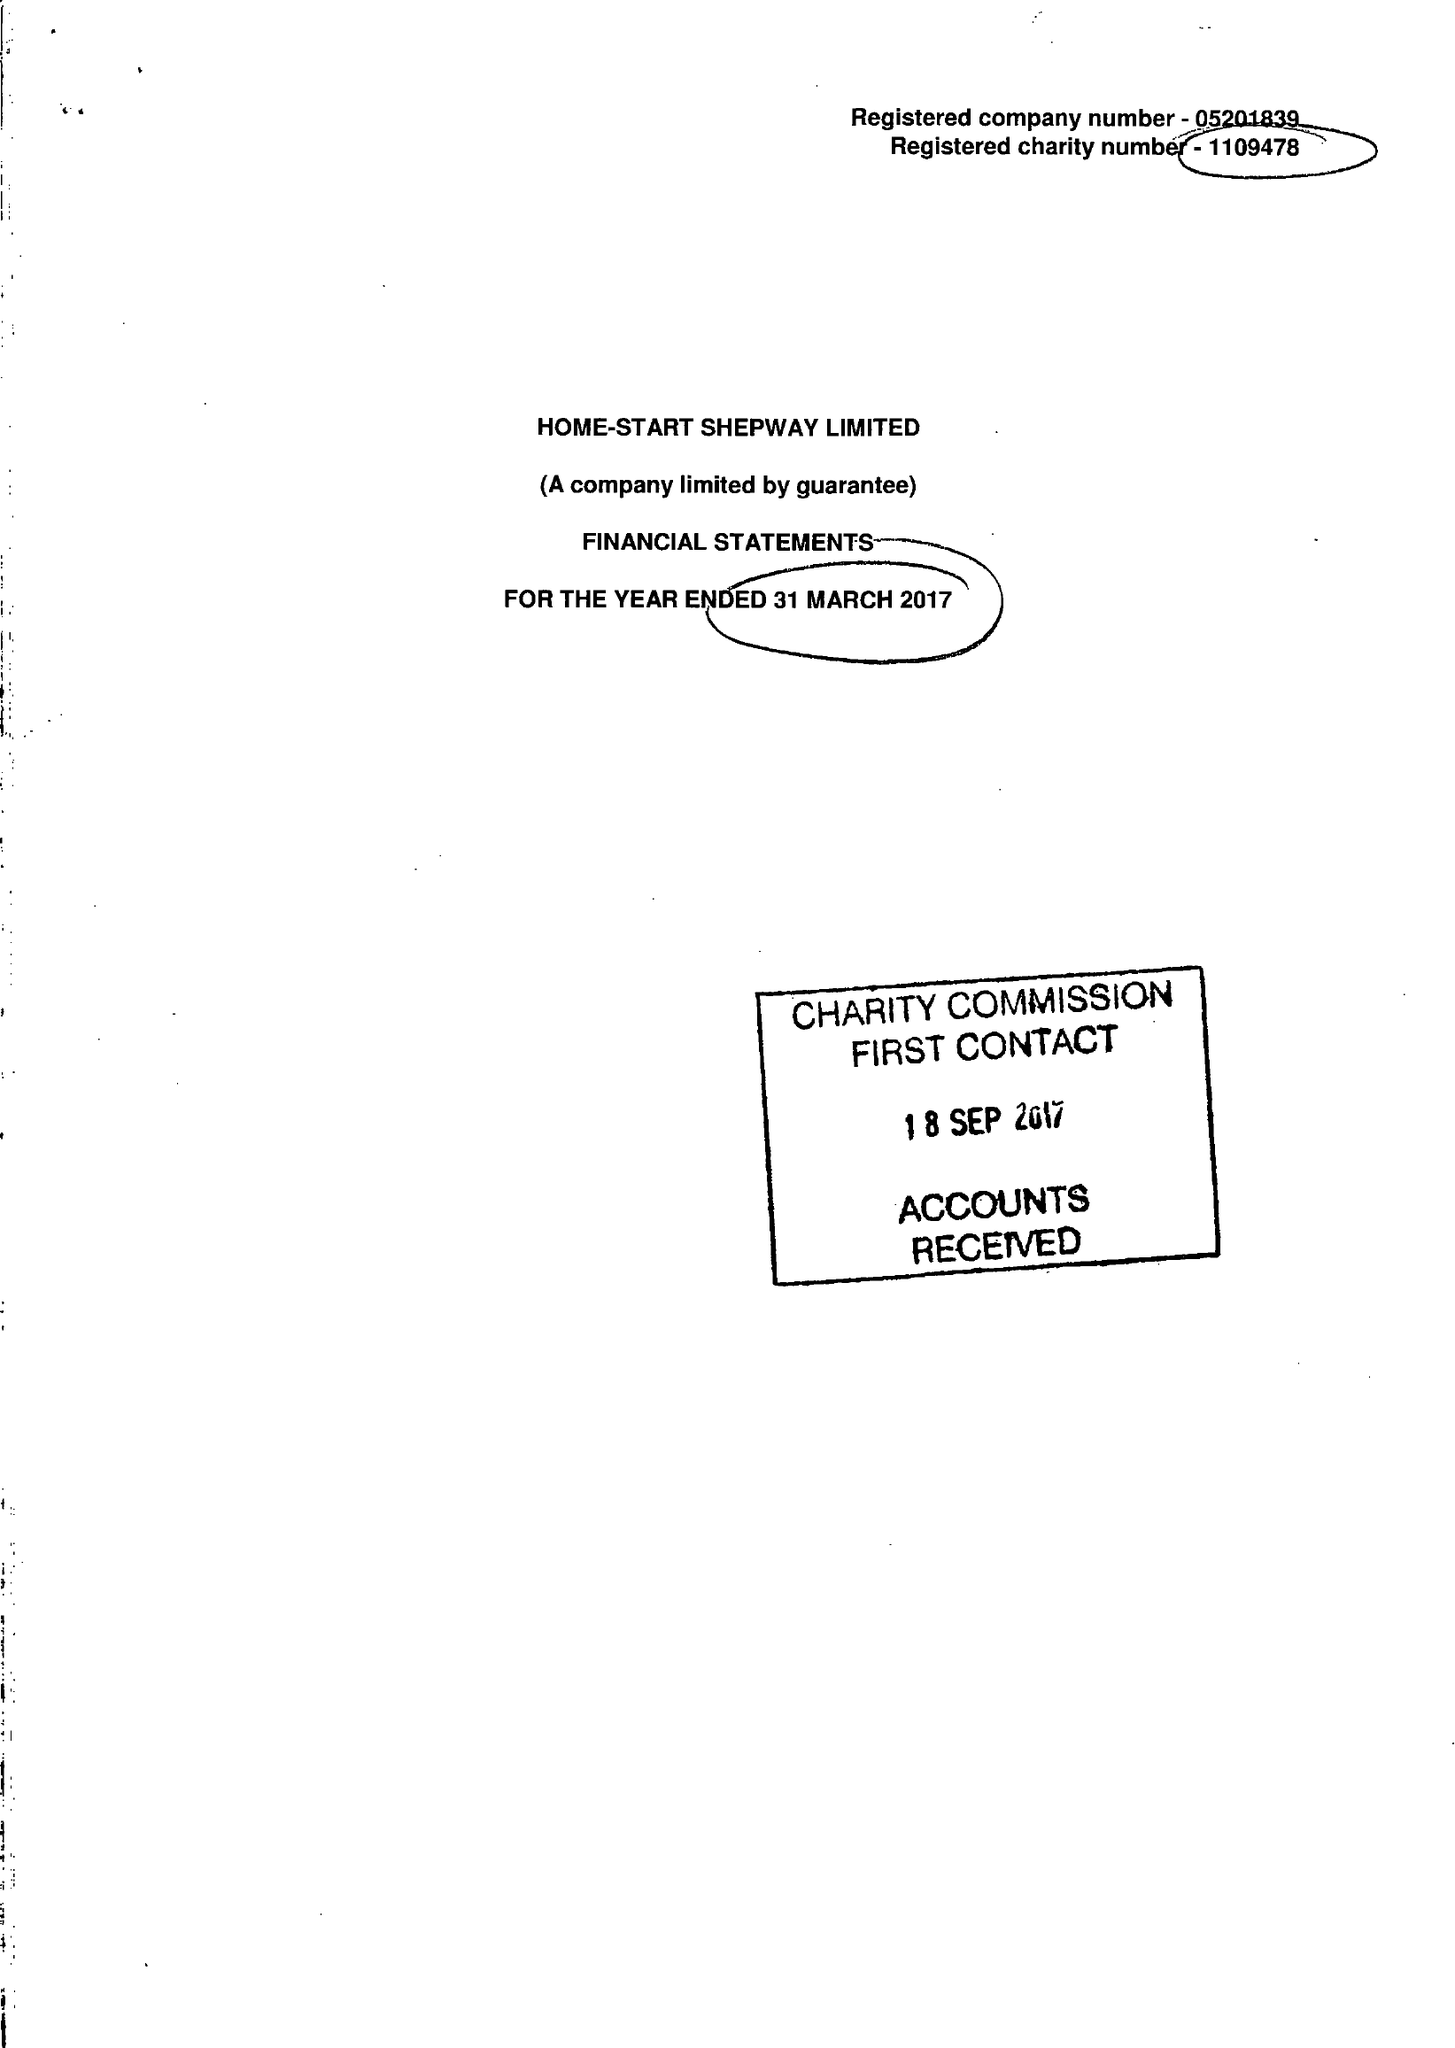What is the value for the charity_name?
Answer the question using a single word or phrase. Home-Start Shepway Ltd. 